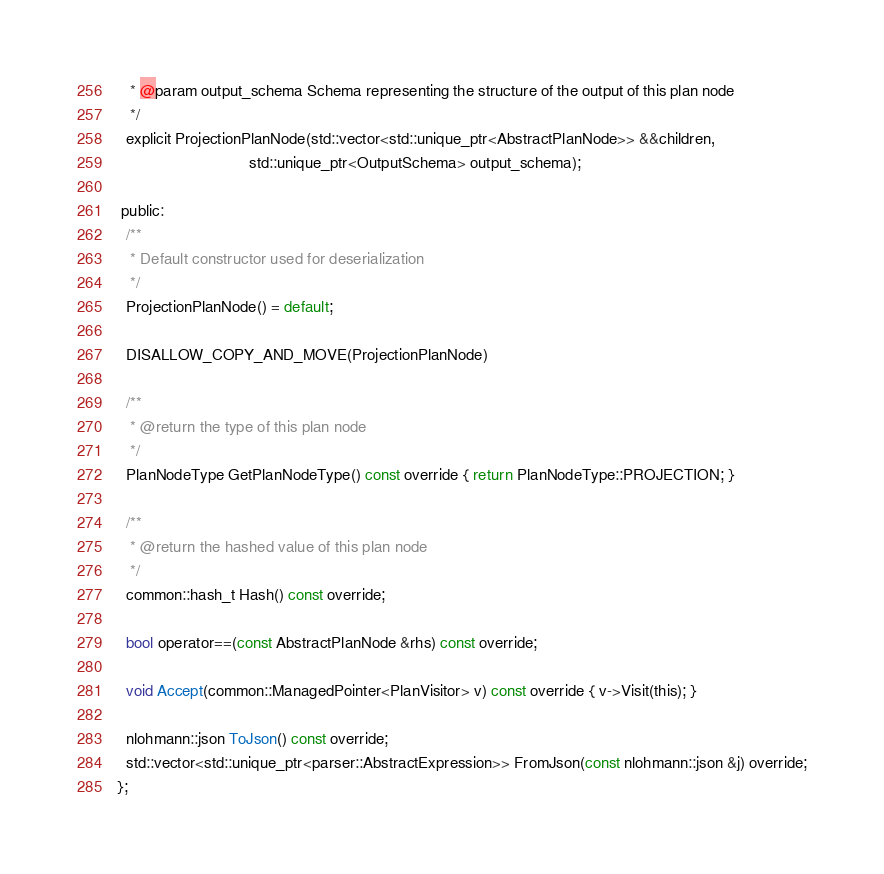Convert code to text. <code><loc_0><loc_0><loc_500><loc_500><_C_>   * @param output_schema Schema representing the structure of the output of this plan node
   */
  explicit ProjectionPlanNode(std::vector<std::unique_ptr<AbstractPlanNode>> &&children,
                              std::unique_ptr<OutputSchema> output_schema);

 public:
  /**
   * Default constructor used for deserialization
   */
  ProjectionPlanNode() = default;

  DISALLOW_COPY_AND_MOVE(ProjectionPlanNode)

  /**
   * @return the type of this plan node
   */
  PlanNodeType GetPlanNodeType() const override { return PlanNodeType::PROJECTION; }

  /**
   * @return the hashed value of this plan node
   */
  common::hash_t Hash() const override;

  bool operator==(const AbstractPlanNode &rhs) const override;

  void Accept(common::ManagedPointer<PlanVisitor> v) const override { v->Visit(this); }

  nlohmann::json ToJson() const override;
  std::vector<std::unique_ptr<parser::AbstractExpression>> FromJson(const nlohmann::json &j) override;
};
</code> 